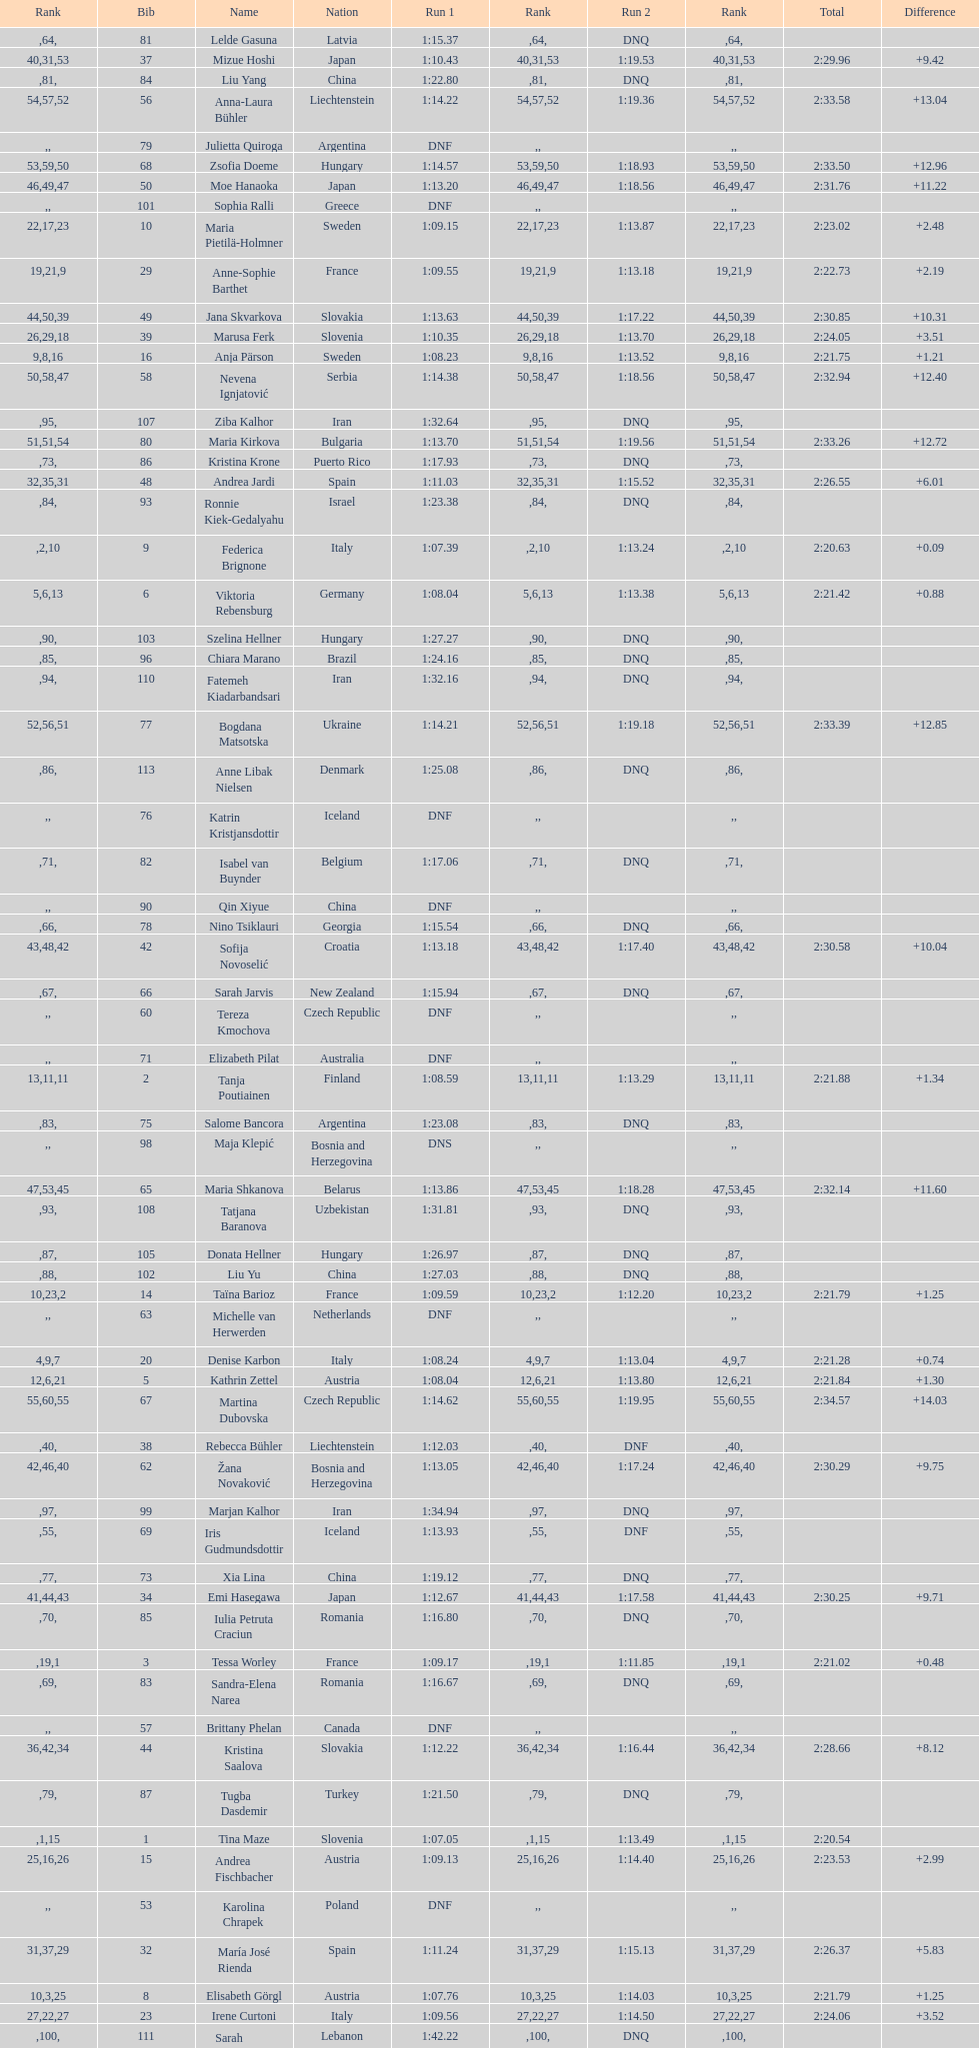How many italians finished in the top ten? 3. 